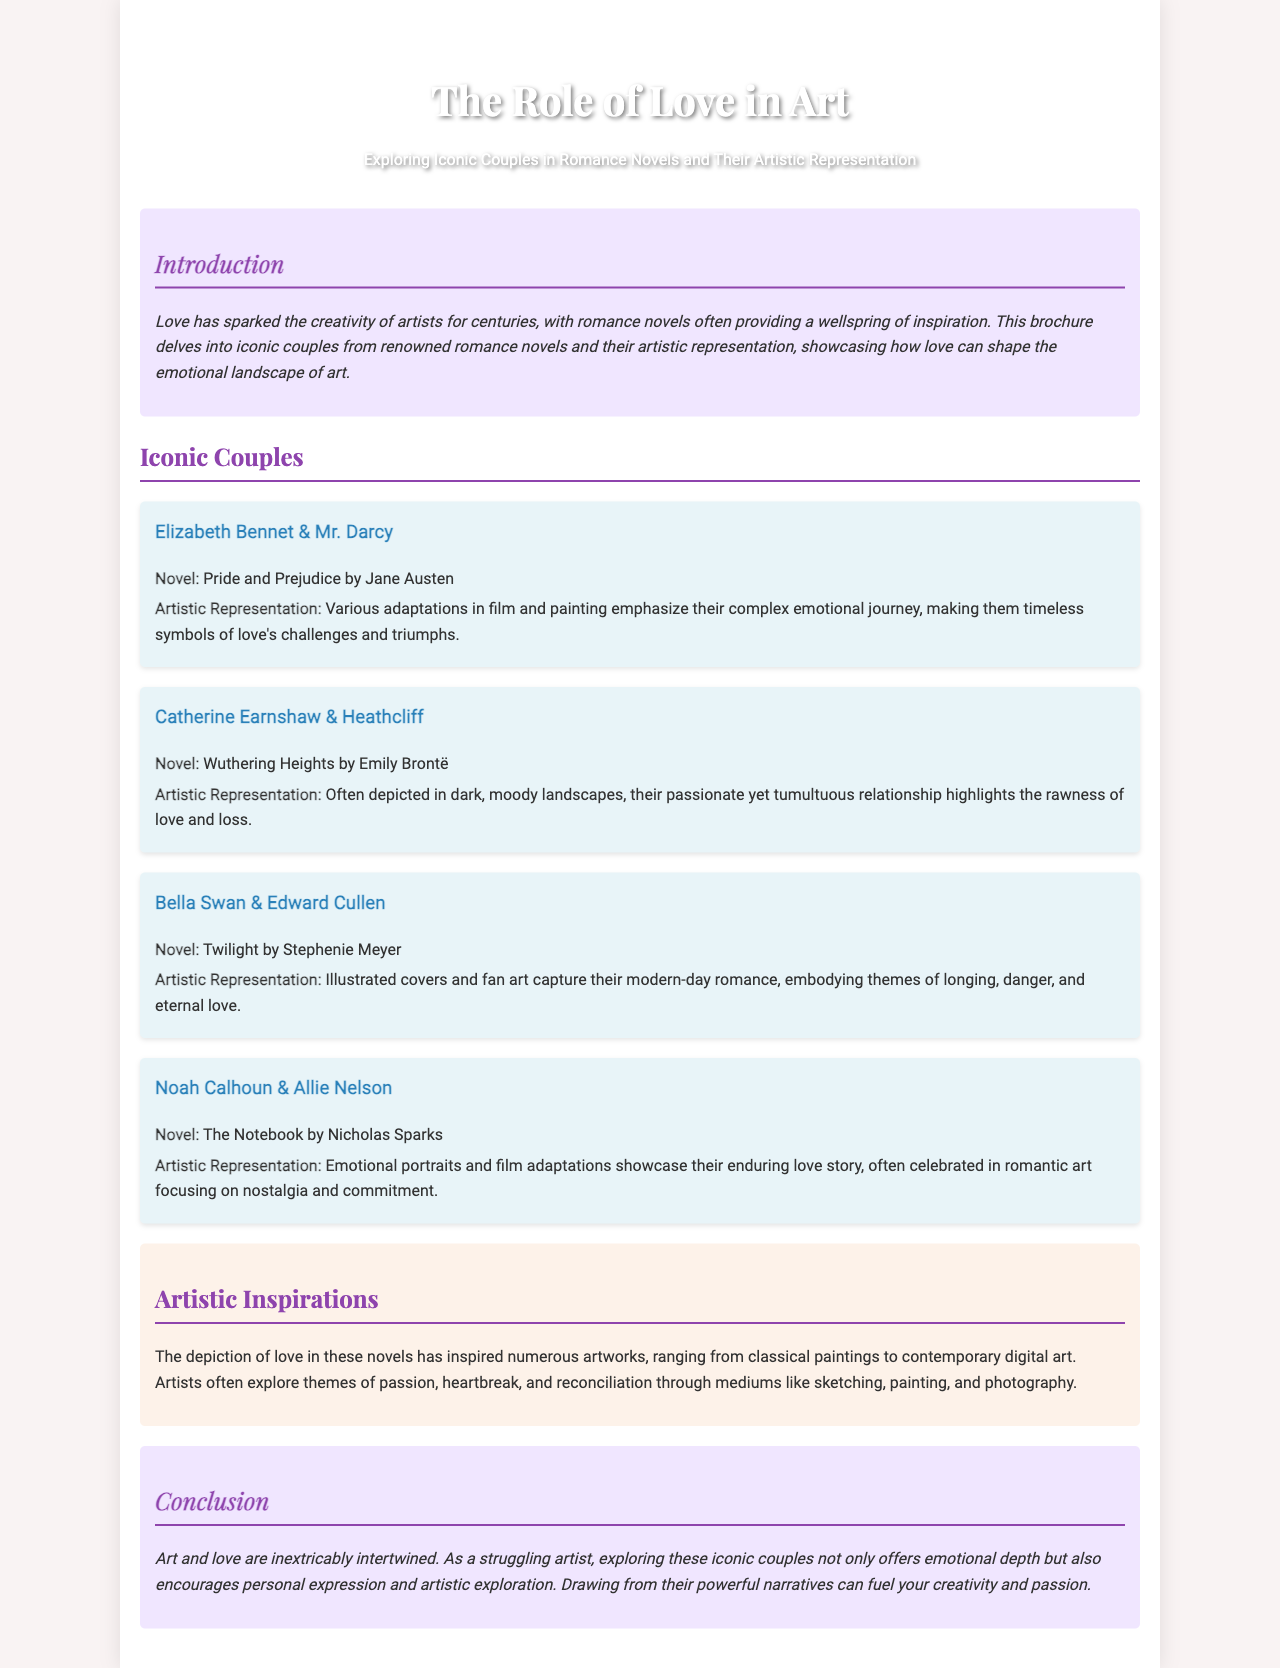What is the title of the brochure? The title of the brochure is found in the header section of the document.
Answer: The Role of Love in Art Who wrote "Pride and Prejudice"? The author of "Pride and Prejudice" is mentioned in the description of its iconic couple.
Answer: Jane Austen What is the artistic representation of Elizabeth Bennet & Mr. Darcy? The artistic representation is described in the section dedicated to their couple, highlighting their emotional journey.
Answer: Complex emotional journey Which couple is associated with the novel "The Notebook"? The couple linked to "The Notebook" is provided along with their names in the document.
Answer: Noah Calhoun & Allie Nelson How are Catherine Earnshaw & Heathcliff depicted in art? The document states how their relationship is visually represented in artworks.
Answer: Dark, moody landscapes What themes does the artistic inspirations section focus on? The artistic inspirations section discusses the themes explored by artists inspired by the novels.
Answer: Passion, heartbreak, reconciliation How does the conclusion relate love and art? The conclusion summarises the relationship between love and art as described earlier in the brochure.
Answer: Inextricably intertwined What type of document is this? The specific type of document can be identified by its purpose and content as described in the introduction.
Answer: Brochure 